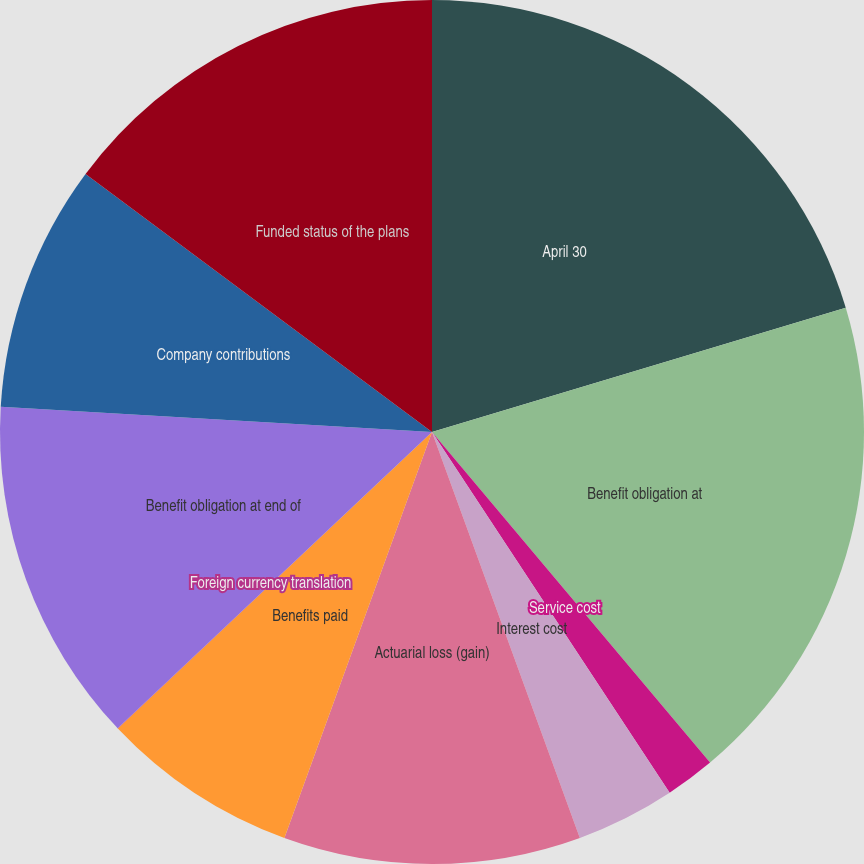Convert chart to OTSL. <chart><loc_0><loc_0><loc_500><loc_500><pie_chart><fcel>April 30<fcel>Benefit obligation at<fcel>Service cost<fcel>Interest cost<fcel>Actuarial loss (gain)<fcel>Benefits paid<fcel>Foreign currency translation<fcel>Benefit obligation at end of<fcel>Company contributions<fcel>Funded status of the plans<nl><fcel>20.36%<fcel>18.51%<fcel>1.86%<fcel>3.71%<fcel>11.11%<fcel>7.41%<fcel>0.01%<fcel>12.96%<fcel>9.26%<fcel>14.81%<nl></chart> 